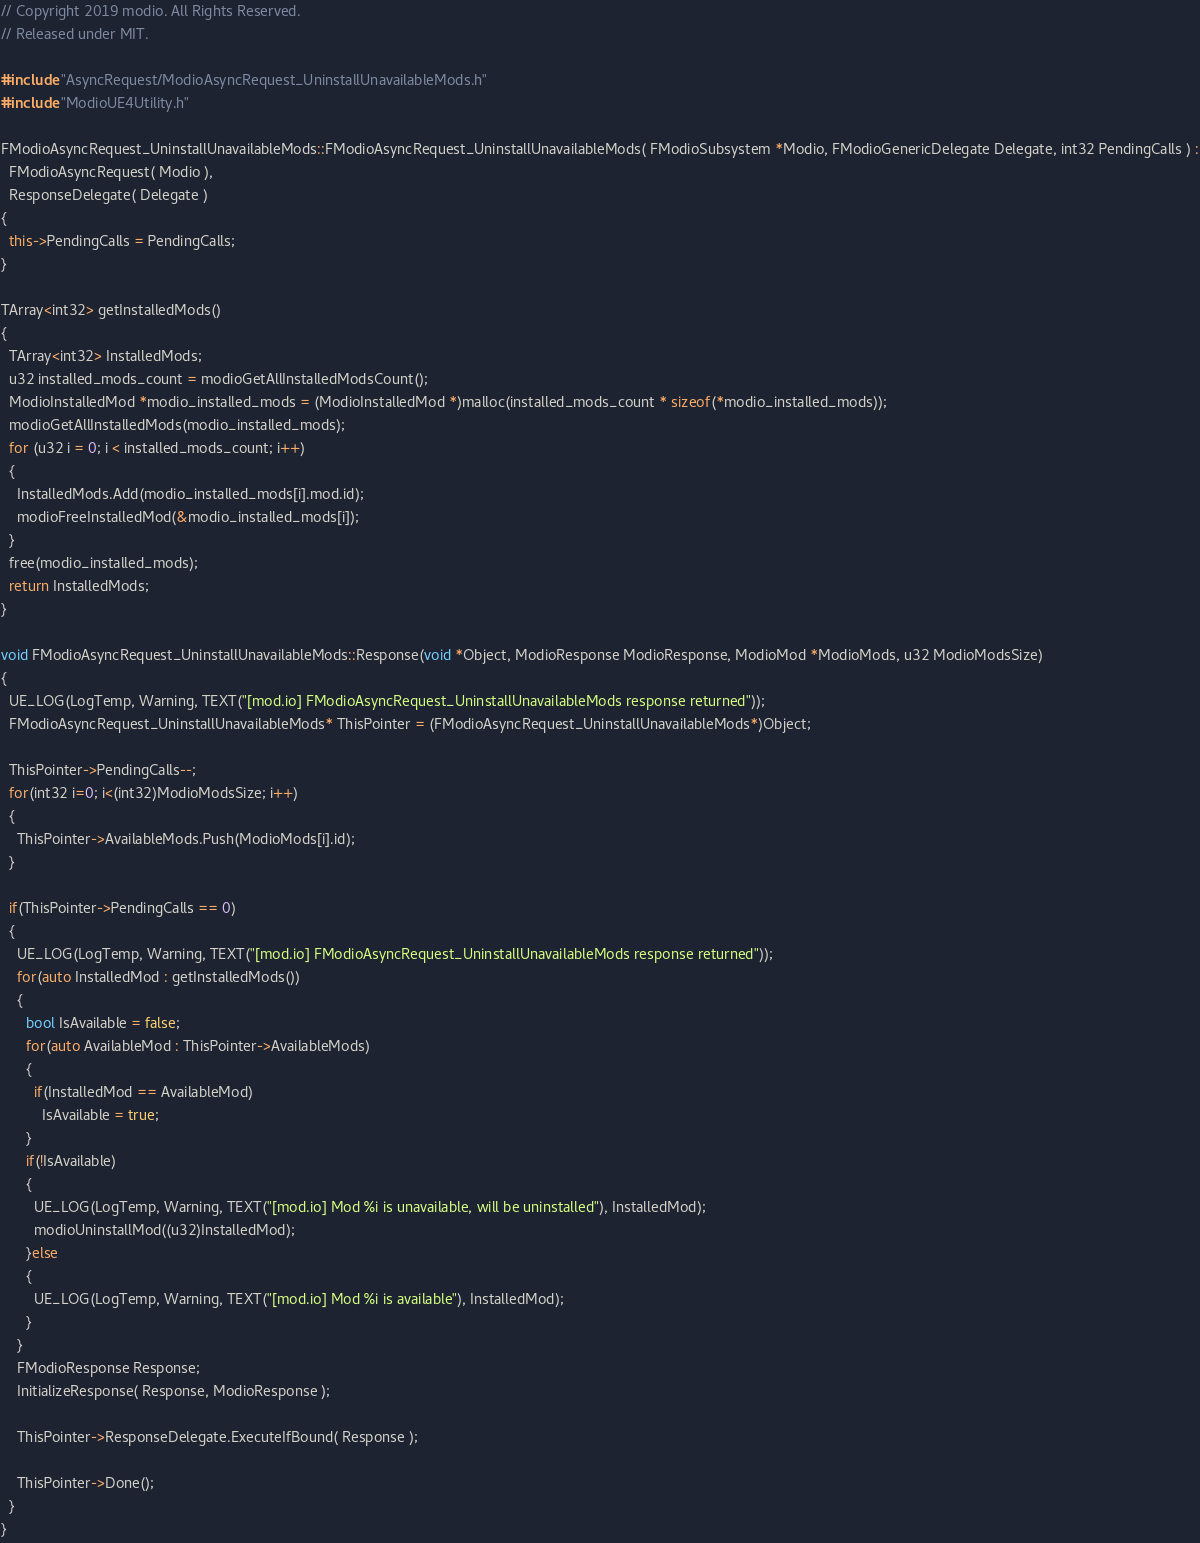Convert code to text. <code><loc_0><loc_0><loc_500><loc_500><_C++_>// Copyright 2019 modio. All Rights Reserved.
// Released under MIT.

#include "AsyncRequest/ModioAsyncRequest_UninstallUnavailableMods.h"
#include "ModioUE4Utility.h"

FModioAsyncRequest_UninstallUnavailableMods::FModioAsyncRequest_UninstallUnavailableMods( FModioSubsystem *Modio, FModioGenericDelegate Delegate, int32 PendingCalls ) :
  FModioAsyncRequest( Modio ),
  ResponseDelegate( Delegate )
{
  this->PendingCalls = PendingCalls;
}

TArray<int32> getInstalledMods()
{
  TArray<int32> InstalledMods;
  u32 installed_mods_count = modioGetAllInstalledModsCount();
  ModioInstalledMod *modio_installed_mods = (ModioInstalledMod *)malloc(installed_mods_count * sizeof(*modio_installed_mods));
  modioGetAllInstalledMods(modio_installed_mods);
  for (u32 i = 0; i < installed_mods_count; i++)
  {
    InstalledMods.Add(modio_installed_mods[i].mod.id);
    modioFreeInstalledMod(&modio_installed_mods[i]);
  }
  free(modio_installed_mods);
  return InstalledMods;
}

void FModioAsyncRequest_UninstallUnavailableMods::Response(void *Object, ModioResponse ModioResponse, ModioMod *ModioMods, u32 ModioModsSize)
{
  UE_LOG(LogTemp, Warning, TEXT("[mod.io] FModioAsyncRequest_UninstallUnavailableMods response returned"));
  FModioAsyncRequest_UninstallUnavailableMods* ThisPointer = (FModioAsyncRequest_UninstallUnavailableMods*)Object;

  ThisPointer->PendingCalls--;
  for(int32 i=0; i<(int32)ModioModsSize; i++)
  {
    ThisPointer->AvailableMods.Push(ModioMods[i].id);
  }
  
  if(ThisPointer->PendingCalls == 0)
  {
    UE_LOG(LogTemp, Warning, TEXT("[mod.io] FModioAsyncRequest_UninstallUnavailableMods response returned"));
    for(auto InstalledMod : getInstalledMods())
    {
      bool IsAvailable = false;
      for(auto AvailableMod : ThisPointer->AvailableMods)
      {
        if(InstalledMod == AvailableMod)
          IsAvailable = true;
      }
      if(!IsAvailable)
      {
        UE_LOG(LogTemp, Warning, TEXT("[mod.io] Mod %i is unavailable, will be uninstalled"), InstalledMod);
        modioUninstallMod((u32)InstalledMod);
      }else
      {
        UE_LOG(LogTemp, Warning, TEXT("[mod.io] Mod %i is available"), InstalledMod);
      }
    }
    FModioResponse Response;
    InitializeResponse( Response, ModioResponse );

    ThisPointer->ResponseDelegate.ExecuteIfBound( Response );
    
    ThisPointer->Done();
  }
}</code> 